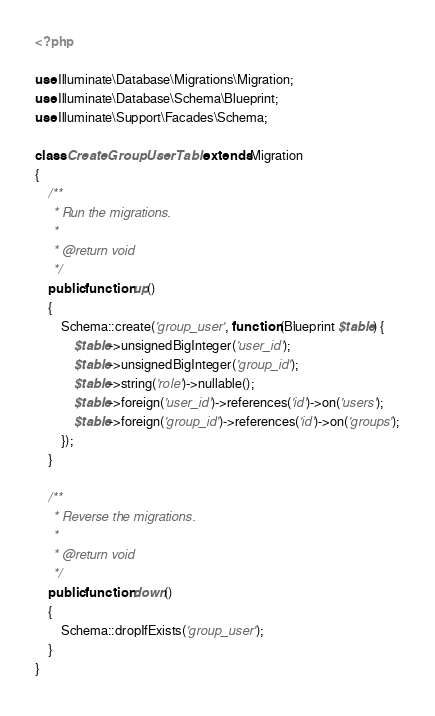Convert code to text. <code><loc_0><loc_0><loc_500><loc_500><_PHP_><?php

use Illuminate\Database\Migrations\Migration;
use Illuminate\Database\Schema\Blueprint;
use Illuminate\Support\Facades\Schema;

class CreateGroupUserTable extends Migration
{
    /**
     * Run the migrations.
     *
     * @return void
     */
    public function up()
    {
        Schema::create('group_user', function (Blueprint $table) {
            $table->unsignedBigInteger('user_id');
            $table->unsignedBigInteger('group_id');
            $table->string('role')->nullable();
            $table->foreign('user_id')->references('id')->on('users');
            $table->foreign('group_id')->references('id')->on('groups');
        });
    }

    /**
     * Reverse the migrations.
     *
     * @return void
     */
    public function down()
    {
        Schema::dropIfExists('group_user');
    }
}
</code> 